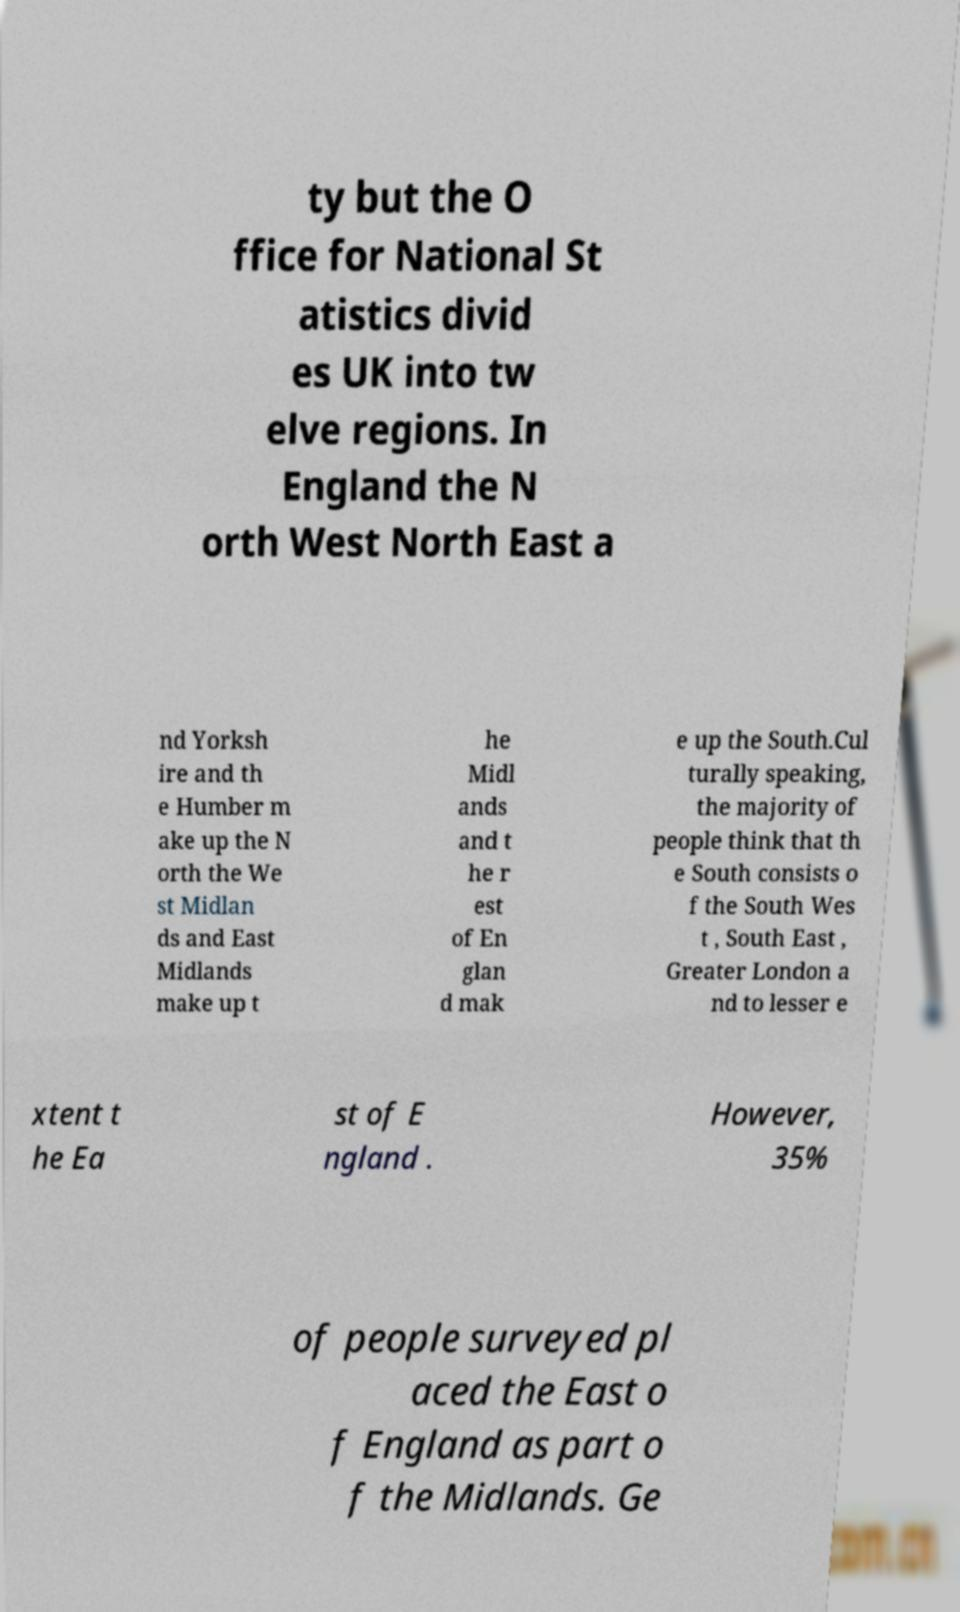Can you read and provide the text displayed in the image?This photo seems to have some interesting text. Can you extract and type it out for me? ty but the O ffice for National St atistics divid es UK into tw elve regions. In England the N orth West North East a nd Yorksh ire and th e Humber m ake up the N orth the We st Midlan ds and East Midlands make up t he Midl ands and t he r est of En glan d mak e up the South.Cul turally speaking, the majority of people think that th e South consists o f the South Wes t , South East , Greater London a nd to lesser e xtent t he Ea st of E ngland . However, 35% of people surveyed pl aced the East o f England as part o f the Midlands. Ge 